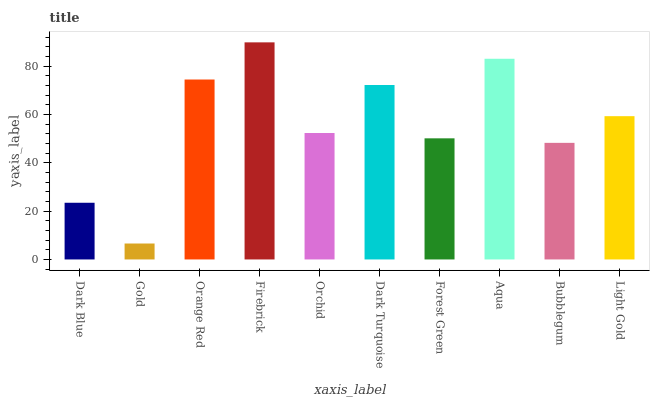Is Gold the minimum?
Answer yes or no. Yes. Is Firebrick the maximum?
Answer yes or no. Yes. Is Orange Red the minimum?
Answer yes or no. No. Is Orange Red the maximum?
Answer yes or no. No. Is Orange Red greater than Gold?
Answer yes or no. Yes. Is Gold less than Orange Red?
Answer yes or no. Yes. Is Gold greater than Orange Red?
Answer yes or no. No. Is Orange Red less than Gold?
Answer yes or no. No. Is Light Gold the high median?
Answer yes or no. Yes. Is Orchid the low median?
Answer yes or no. Yes. Is Orange Red the high median?
Answer yes or no. No. Is Orange Red the low median?
Answer yes or no. No. 